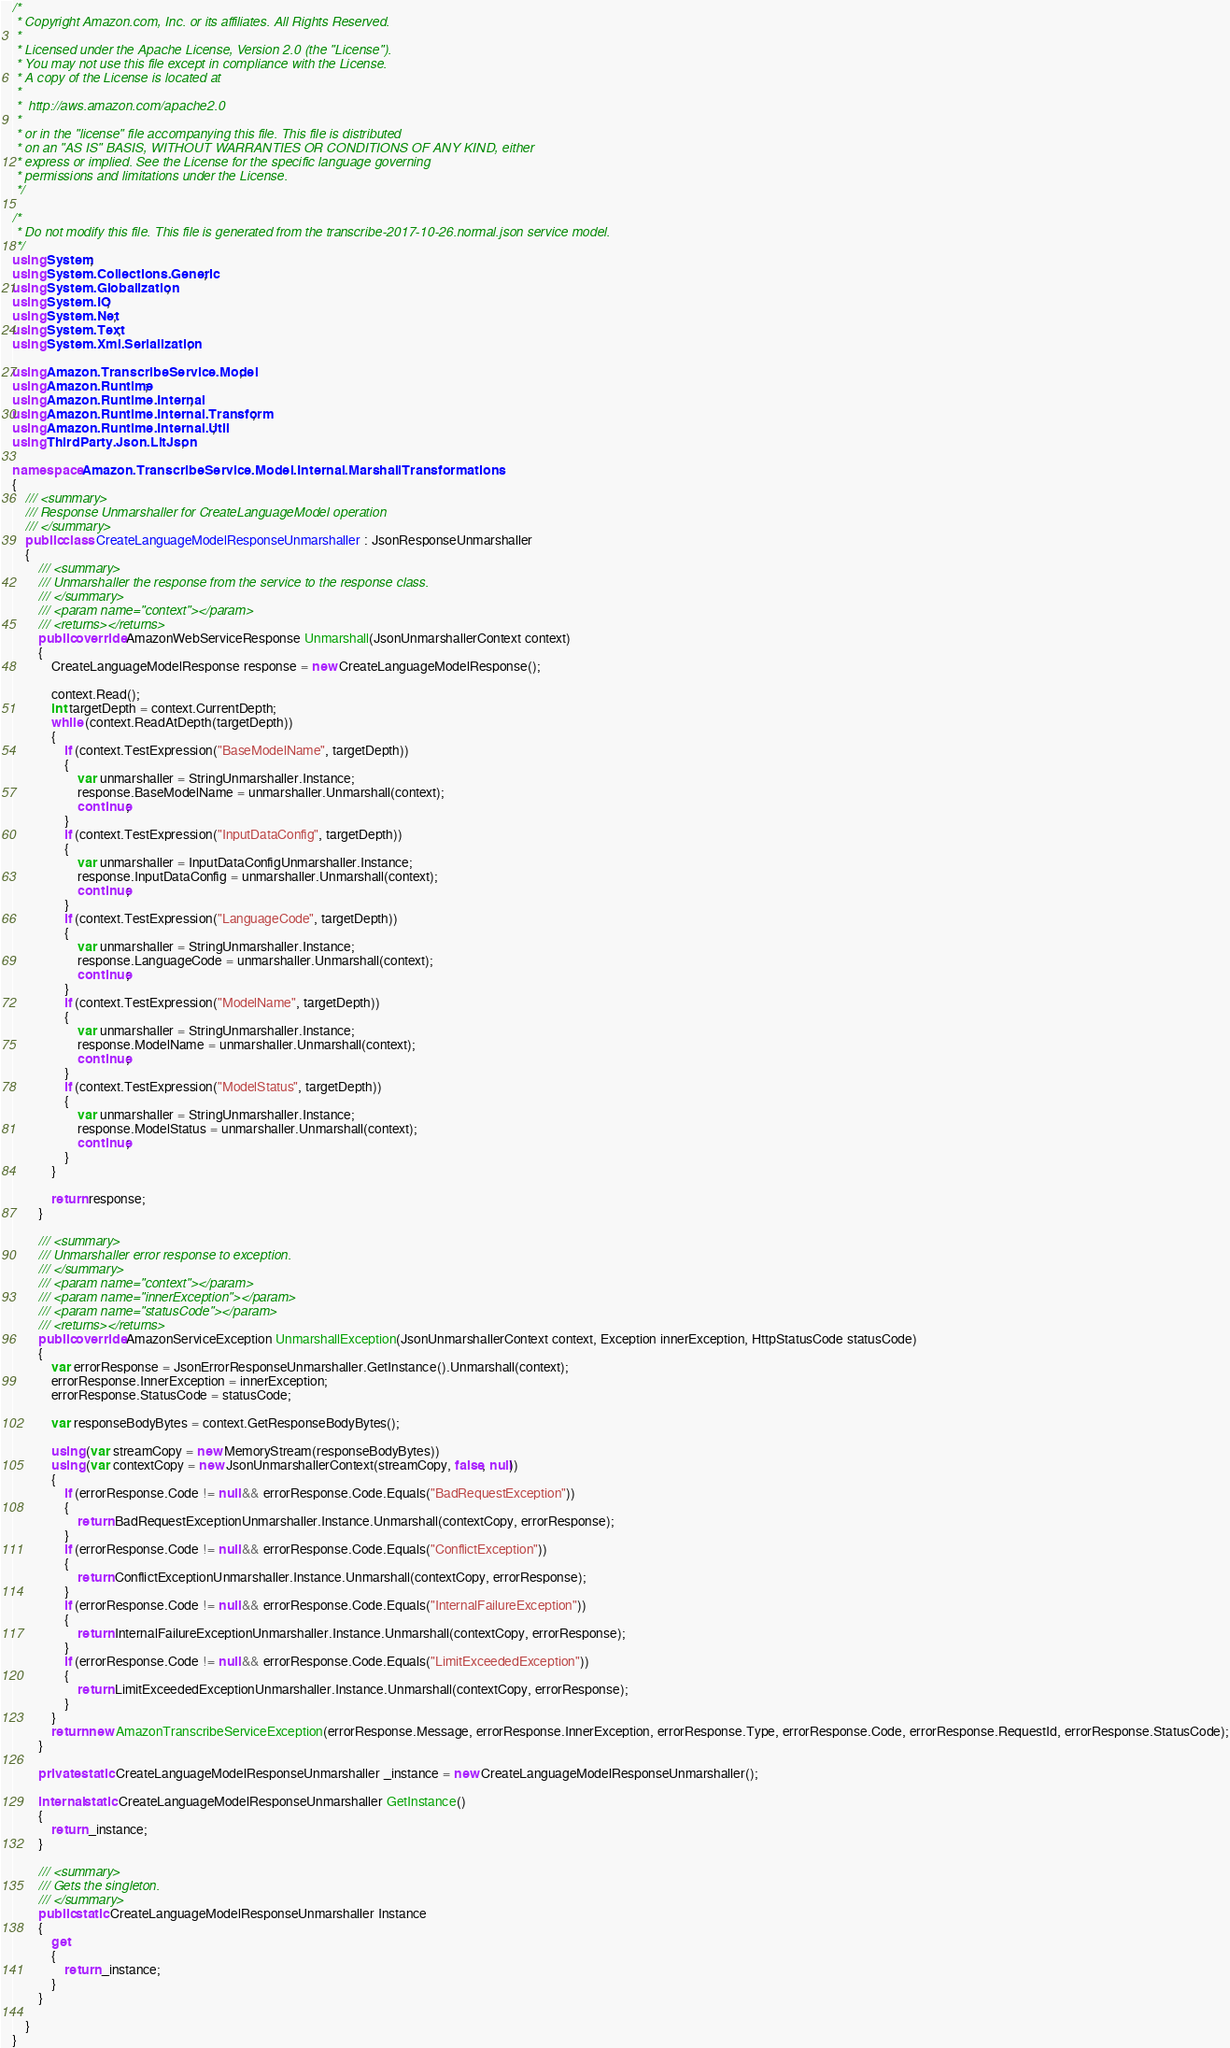<code> <loc_0><loc_0><loc_500><loc_500><_C#_>/*
 * Copyright Amazon.com, Inc. or its affiliates. All Rights Reserved.
 * 
 * Licensed under the Apache License, Version 2.0 (the "License").
 * You may not use this file except in compliance with the License.
 * A copy of the License is located at
 * 
 *  http://aws.amazon.com/apache2.0
 * 
 * or in the "license" file accompanying this file. This file is distributed
 * on an "AS IS" BASIS, WITHOUT WARRANTIES OR CONDITIONS OF ANY KIND, either
 * express or implied. See the License for the specific language governing
 * permissions and limitations under the License.
 */

/*
 * Do not modify this file. This file is generated from the transcribe-2017-10-26.normal.json service model.
 */
using System;
using System.Collections.Generic;
using System.Globalization;
using System.IO;
using System.Net;
using System.Text;
using System.Xml.Serialization;

using Amazon.TranscribeService.Model;
using Amazon.Runtime;
using Amazon.Runtime.Internal;
using Amazon.Runtime.Internal.Transform;
using Amazon.Runtime.Internal.Util;
using ThirdParty.Json.LitJson;

namespace Amazon.TranscribeService.Model.Internal.MarshallTransformations
{
    /// <summary>
    /// Response Unmarshaller for CreateLanguageModel operation
    /// </summary>  
    public class CreateLanguageModelResponseUnmarshaller : JsonResponseUnmarshaller
    {
        /// <summary>
        /// Unmarshaller the response from the service to the response class.
        /// </summary>  
        /// <param name="context"></param>
        /// <returns></returns>
        public override AmazonWebServiceResponse Unmarshall(JsonUnmarshallerContext context)
        {
            CreateLanguageModelResponse response = new CreateLanguageModelResponse();

            context.Read();
            int targetDepth = context.CurrentDepth;
            while (context.ReadAtDepth(targetDepth))
            {
                if (context.TestExpression("BaseModelName", targetDepth))
                {
                    var unmarshaller = StringUnmarshaller.Instance;
                    response.BaseModelName = unmarshaller.Unmarshall(context);
                    continue;
                }
                if (context.TestExpression("InputDataConfig", targetDepth))
                {
                    var unmarshaller = InputDataConfigUnmarshaller.Instance;
                    response.InputDataConfig = unmarshaller.Unmarshall(context);
                    continue;
                }
                if (context.TestExpression("LanguageCode", targetDepth))
                {
                    var unmarshaller = StringUnmarshaller.Instance;
                    response.LanguageCode = unmarshaller.Unmarshall(context);
                    continue;
                }
                if (context.TestExpression("ModelName", targetDepth))
                {
                    var unmarshaller = StringUnmarshaller.Instance;
                    response.ModelName = unmarshaller.Unmarshall(context);
                    continue;
                }
                if (context.TestExpression("ModelStatus", targetDepth))
                {
                    var unmarshaller = StringUnmarshaller.Instance;
                    response.ModelStatus = unmarshaller.Unmarshall(context);
                    continue;
                }
            }

            return response;
        }

        /// <summary>
        /// Unmarshaller error response to exception.
        /// </summary>  
        /// <param name="context"></param>
        /// <param name="innerException"></param>
        /// <param name="statusCode"></param>
        /// <returns></returns>
        public override AmazonServiceException UnmarshallException(JsonUnmarshallerContext context, Exception innerException, HttpStatusCode statusCode)
        {
            var errorResponse = JsonErrorResponseUnmarshaller.GetInstance().Unmarshall(context);
            errorResponse.InnerException = innerException;
            errorResponse.StatusCode = statusCode;

            var responseBodyBytes = context.GetResponseBodyBytes();

            using (var streamCopy = new MemoryStream(responseBodyBytes))
            using (var contextCopy = new JsonUnmarshallerContext(streamCopy, false, null))
            {
                if (errorResponse.Code != null && errorResponse.Code.Equals("BadRequestException"))
                {
                    return BadRequestExceptionUnmarshaller.Instance.Unmarshall(contextCopy, errorResponse);
                }
                if (errorResponse.Code != null && errorResponse.Code.Equals("ConflictException"))
                {
                    return ConflictExceptionUnmarshaller.Instance.Unmarshall(contextCopy, errorResponse);
                }
                if (errorResponse.Code != null && errorResponse.Code.Equals("InternalFailureException"))
                {
                    return InternalFailureExceptionUnmarshaller.Instance.Unmarshall(contextCopy, errorResponse);
                }
                if (errorResponse.Code != null && errorResponse.Code.Equals("LimitExceededException"))
                {
                    return LimitExceededExceptionUnmarshaller.Instance.Unmarshall(contextCopy, errorResponse);
                }
            }
            return new AmazonTranscribeServiceException(errorResponse.Message, errorResponse.InnerException, errorResponse.Type, errorResponse.Code, errorResponse.RequestId, errorResponse.StatusCode);
        }

        private static CreateLanguageModelResponseUnmarshaller _instance = new CreateLanguageModelResponseUnmarshaller();        

        internal static CreateLanguageModelResponseUnmarshaller GetInstance()
        {
            return _instance;
        }

        /// <summary>
        /// Gets the singleton.
        /// </summary>  
        public static CreateLanguageModelResponseUnmarshaller Instance
        {
            get
            {
                return _instance;
            }
        }

    }
}</code> 